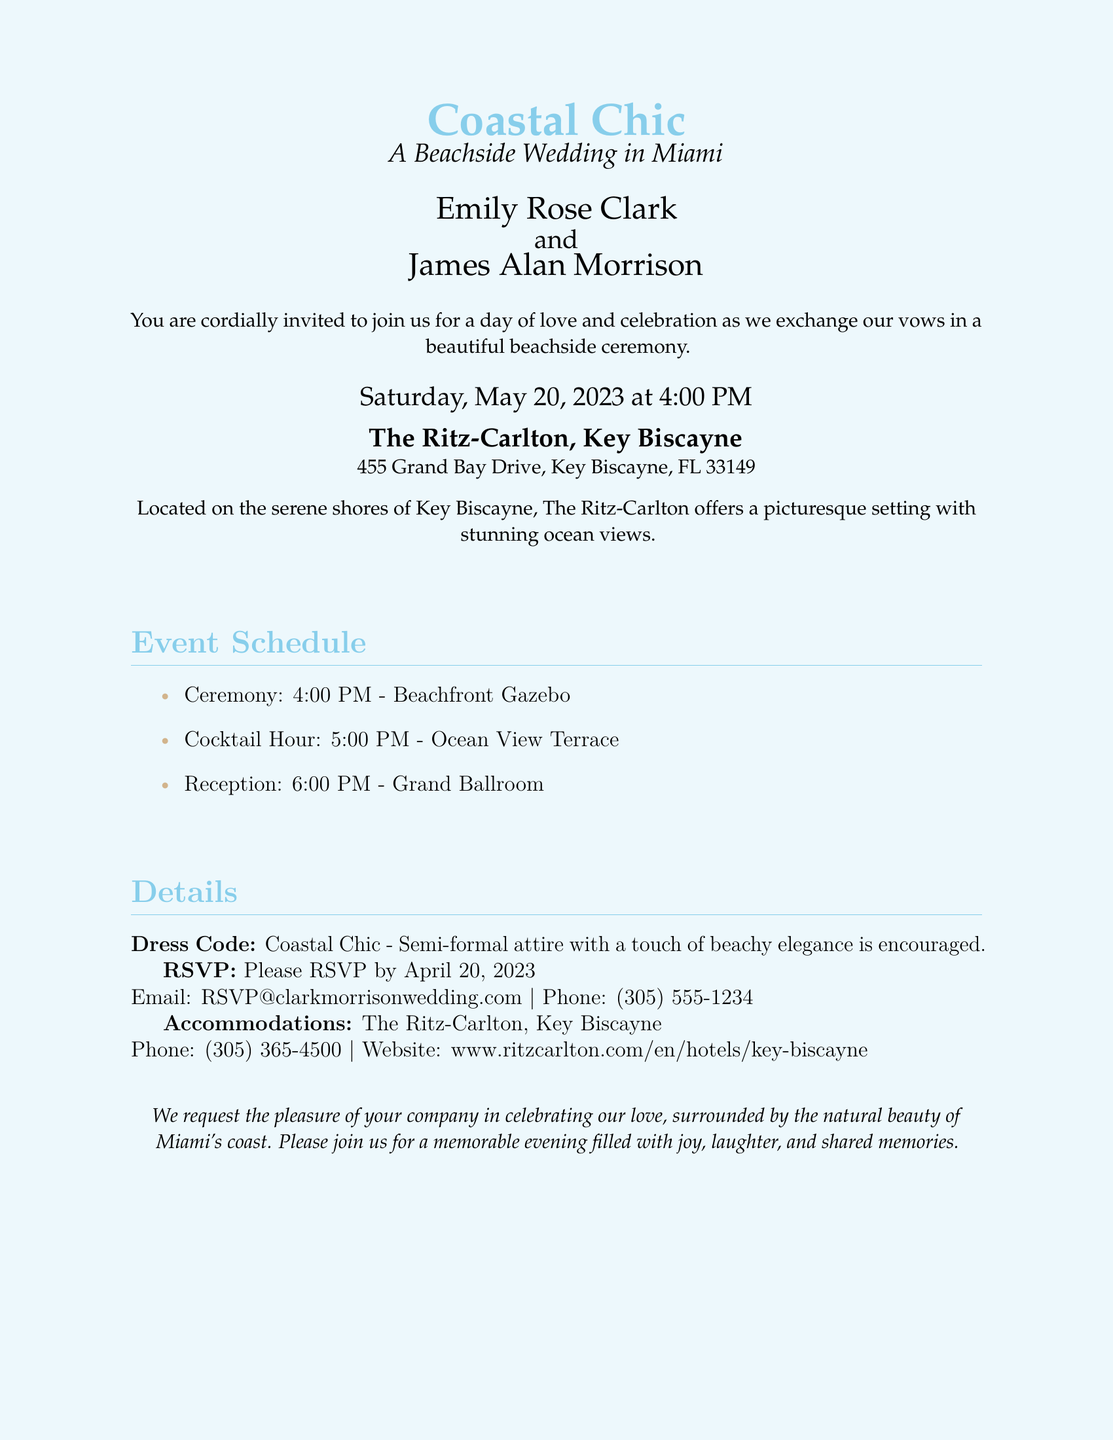What is the name of the bride? The document lists the bride's name as Emily Rose Clark.
Answer: Emily Rose Clark What is the name of the groom? The document lists the groom's name as James Alan Morrison.
Answer: James Alan Morrison What date is the wedding? The wedding is scheduled for Saturday, May 20, 2023.
Answer: May 20, 2023 What is the venue for the ceremony? The ceremony will take place at The Ritz-Carlton, Key Biscayne.
Answer: The Ritz-Carlton, Key Biscayne What time does the reception start? The reception is scheduled to start at 6:00 PM.
Answer: 6:00 PM What is the dress code for the wedding? The dress code specified is "Coastal Chic."
Answer: Coastal Chic What is the RSVP deadline? Guests are requested to RSVP by April 20, 2023.
Answer: April 20, 2023 How many events are listed in the schedule? There are three events listed: Ceremony, Cocktail Hour, and Reception.
Answer: Three What type of accommodations are mentioned? The document mentions accommodations at The Ritz-Carlton, Key Biscayne.
Answer: The Ritz-Carlton, Key Biscayne What is the email address for RSVP? The email address provided for RSVP is RSVP@clarkmorrisonwedding.com.
Answer: RSVP@clarkmorrisonwedding.com 